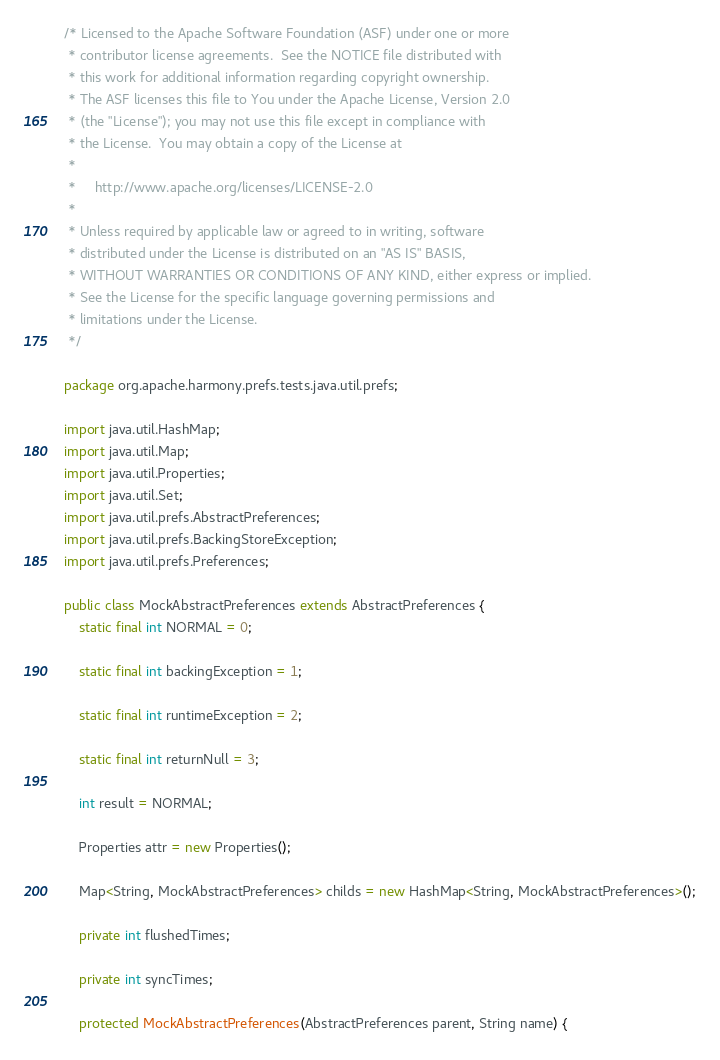<code> <loc_0><loc_0><loc_500><loc_500><_Java_>/* Licensed to the Apache Software Foundation (ASF) under one or more
 * contributor license agreements.  See the NOTICE file distributed with
 * this work for additional information regarding copyright ownership.
 * The ASF licenses this file to You under the Apache License, Version 2.0
 * (the "License"); you may not use this file except in compliance with
 * the License.  You may obtain a copy of the License at
 * 
 *     http://www.apache.org/licenses/LICENSE-2.0
 * 
 * Unless required by applicable law or agreed to in writing, software
 * distributed under the License is distributed on an "AS IS" BASIS,
 * WITHOUT WARRANTIES OR CONDITIONS OF ANY KIND, either express or implied.
 * See the License for the specific language governing permissions and
 * limitations under the License.
 */

package org.apache.harmony.prefs.tests.java.util.prefs;

import java.util.HashMap;
import java.util.Map;
import java.util.Properties;
import java.util.Set;
import java.util.prefs.AbstractPreferences;
import java.util.prefs.BackingStoreException;
import java.util.prefs.Preferences;

public class MockAbstractPreferences extends AbstractPreferences {
    static final int NORMAL = 0;

    static final int backingException = 1;

    static final int runtimeException = 2;

    static final int returnNull = 3;

    int result = NORMAL;

    Properties attr = new Properties();

    Map<String, MockAbstractPreferences> childs = new HashMap<String, MockAbstractPreferences>();

    private int flushedTimes;

    private int syncTimes;

    protected MockAbstractPreferences(AbstractPreferences parent, String name) {</code> 